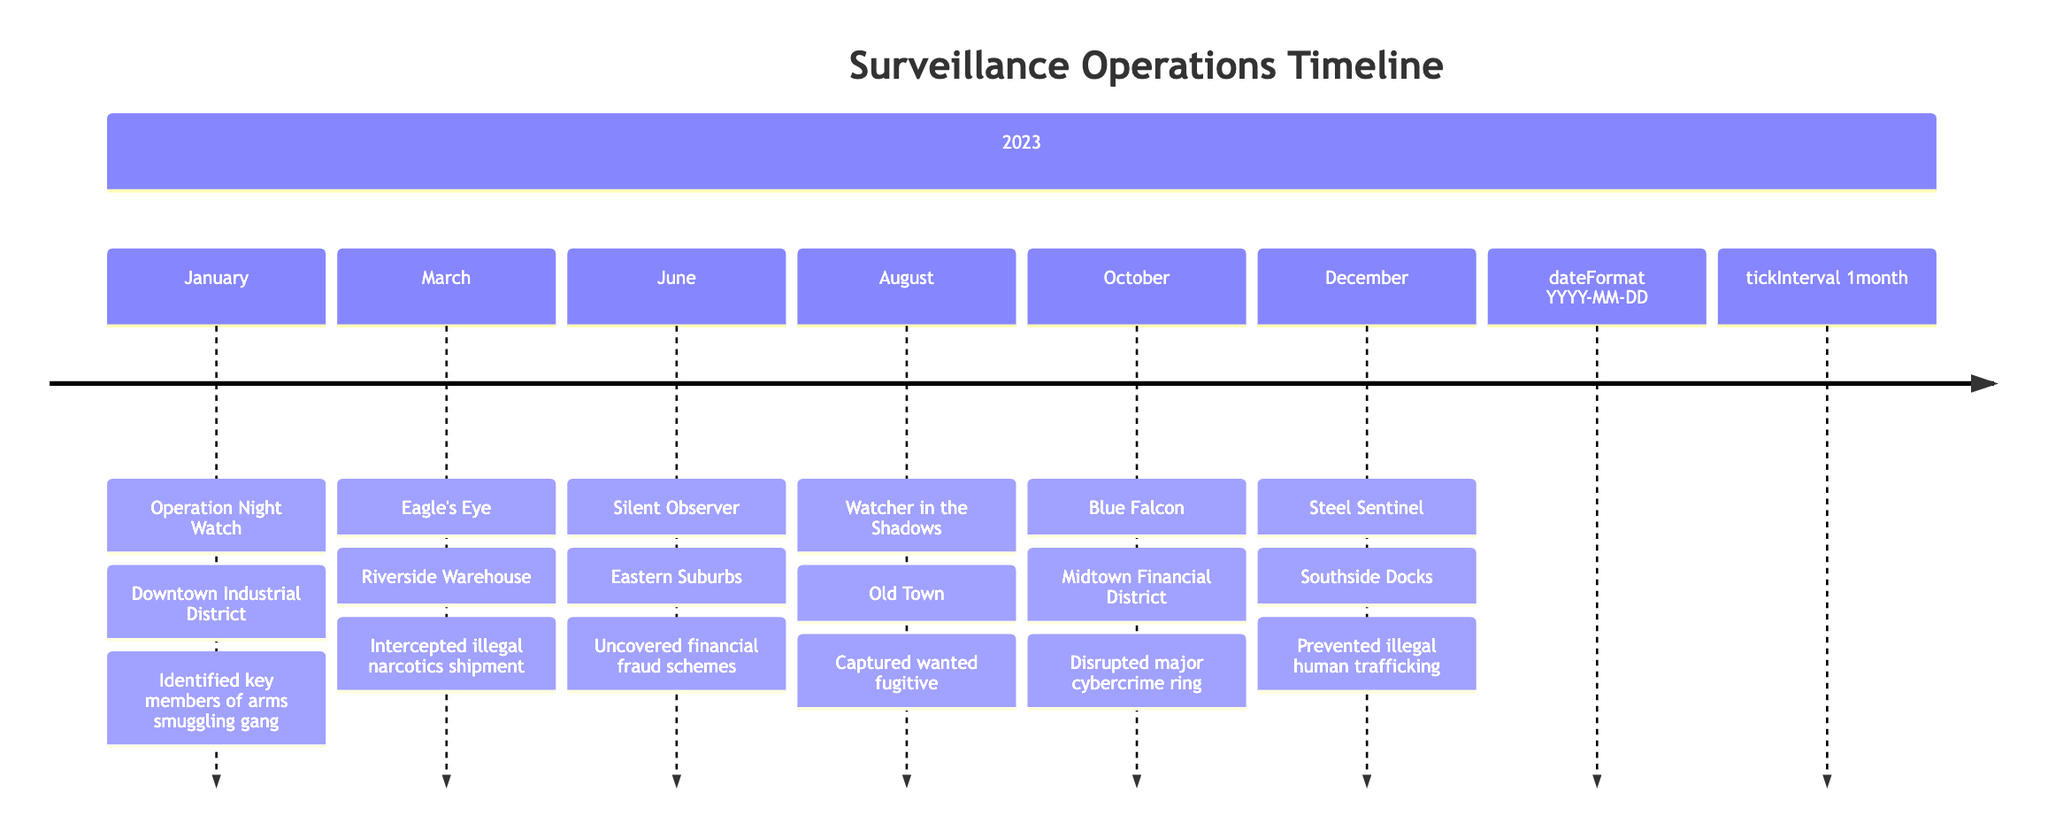What operation occurred on January 15, 2023? The timeline indicates that on January 15, 2023, the operation was "Operation Night Watch."
Answer: Operation Night Watch How many surveillance operations were conducted in 2023? By counting the listed operations in the timeline, there are six operations conducted in the year 2023.
Answer: 6 What was the location of the "Blue Falcon" operation? The timeline shows that "Blue Falcon" was conducted in the Midtown Financial District.
Answer: Midtown Financial District Which operation led to the capture of a wanted fugitive? According to the timeline, "Watcher in the Shadows," held on August 5, 2023, resulted in the capture of a wanted fugitive.
Answer: Watcher in the Shadows What was the outcome of the operation called "Eagle's Eye"? The timeline specifies that "Eagle's Eye" resulted in the interception of an illegal narcotics shipment.
Answer: Interception of illegal narcotics shipment Which operation occurred last in 2023? The last operation listed in the timeline for the year 2023 is "Steel Sentinel," which took place on December 20.
Answer: Steel Sentinel What was the main focus of "Silent Observer"? The timeline indicates that "Silent Observer" involved uncovering financial fraud schemes related to an organized crime syndicate.
Answer: Financial fraud schemes In which month did the operation "Watcher in the Shadows" take place? The operation "Watcher in the Shadows" occurred in August, as listed in the timeline.
Answer: August How many operations were focused on drug-related activities? The timeline shows that there is one operation specifically related to drug activities, which is "Eagle's Eye."
Answer: 1 